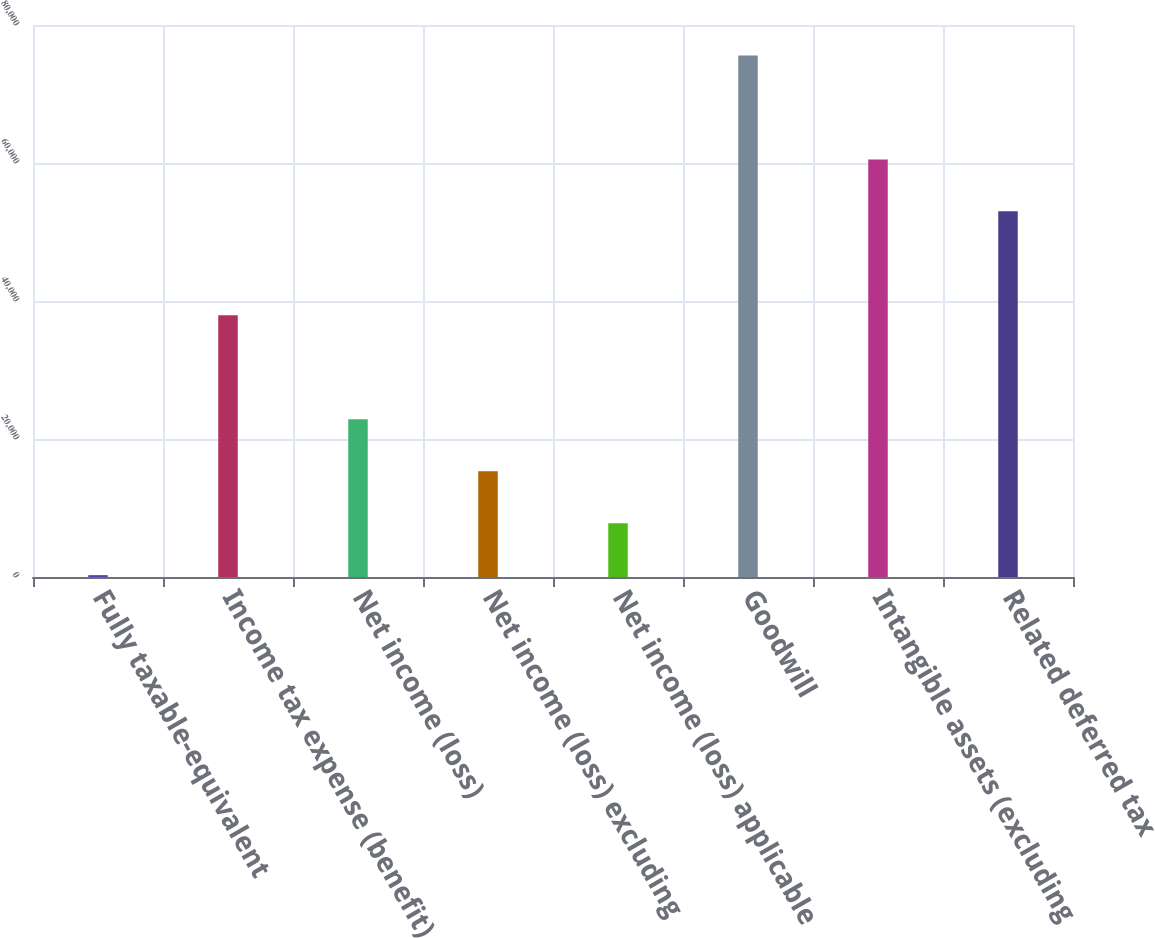<chart> <loc_0><loc_0><loc_500><loc_500><bar_chart><fcel>Fully taxable-equivalent<fcel>Income tax expense (benefit)<fcel>Net income (loss)<fcel>Net income (loss) excluding<fcel>Net income (loss) applicable<fcel>Goodwill<fcel>Intangible assets (excluding<fcel>Related deferred tax<nl><fcel>270<fcel>37927<fcel>22864.2<fcel>15332.8<fcel>7801.4<fcel>75584<fcel>60521.2<fcel>52989.8<nl></chart> 